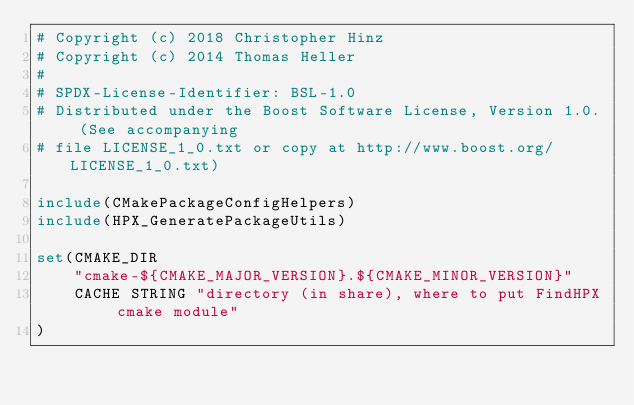<code> <loc_0><loc_0><loc_500><loc_500><_CMake_># Copyright (c) 2018 Christopher Hinz
# Copyright (c) 2014 Thomas Heller
#
# SPDX-License-Identifier: BSL-1.0
# Distributed under the Boost Software License, Version 1.0. (See accompanying
# file LICENSE_1_0.txt or copy at http://www.boost.org/LICENSE_1_0.txt)

include(CMakePackageConfigHelpers)
include(HPX_GeneratePackageUtils)

set(CMAKE_DIR
    "cmake-${CMAKE_MAJOR_VERSION}.${CMAKE_MINOR_VERSION}"
    CACHE STRING "directory (in share), where to put FindHPX cmake module"
)
</code> 